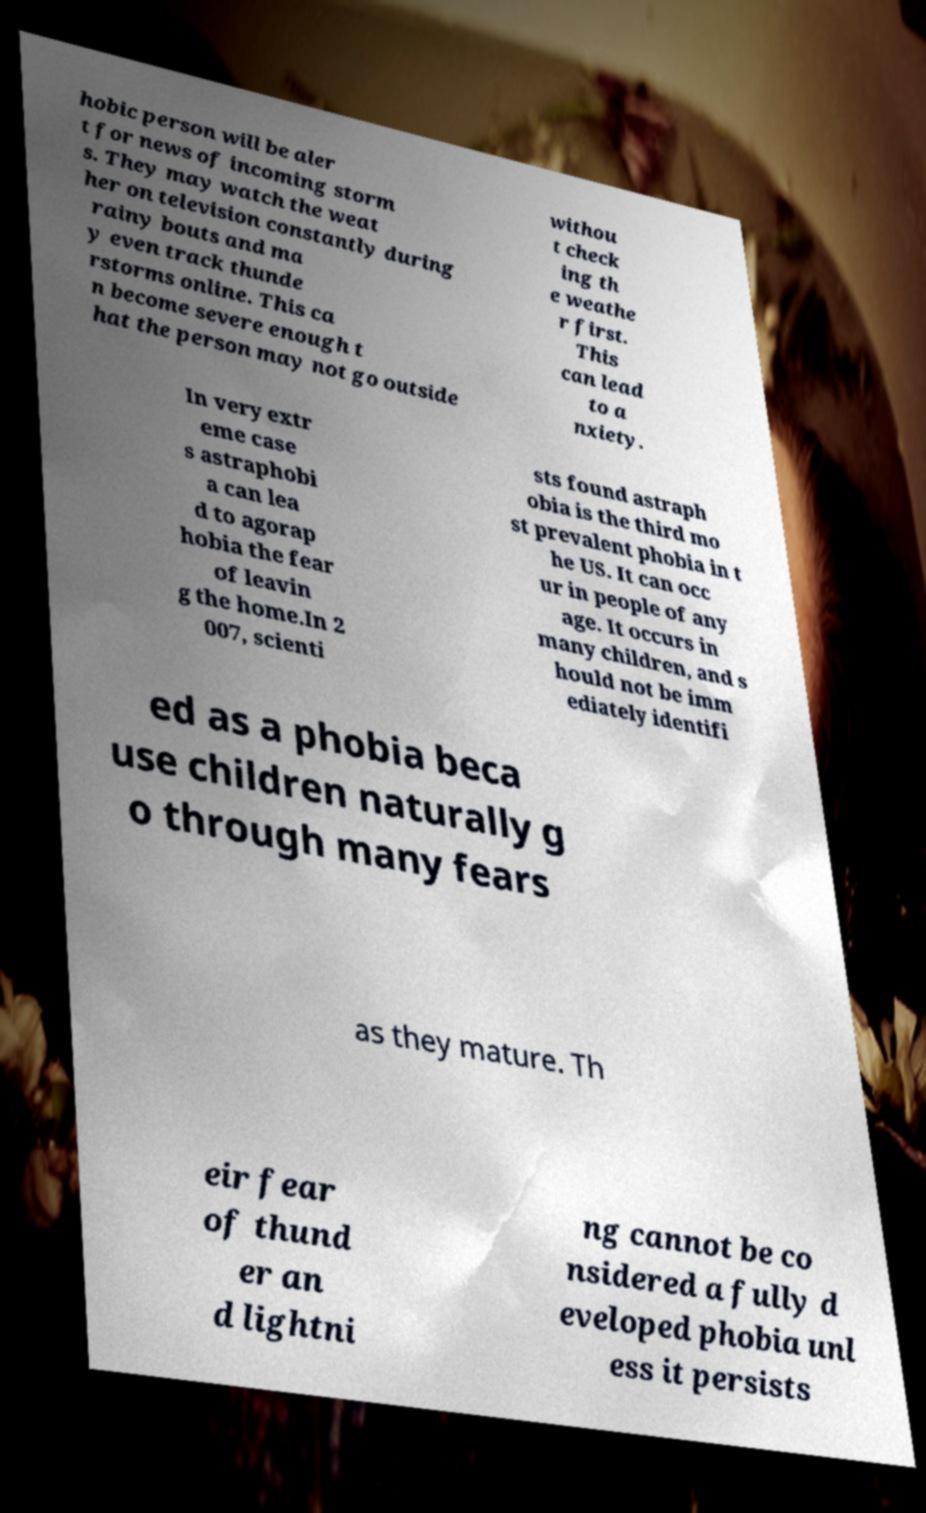Can you read and provide the text displayed in the image?This photo seems to have some interesting text. Can you extract and type it out for me? hobic person will be aler t for news of incoming storm s. They may watch the weat her on television constantly during rainy bouts and ma y even track thunde rstorms online. This ca n become severe enough t hat the person may not go outside withou t check ing th e weathe r first. This can lead to a nxiety. In very extr eme case s astraphobi a can lea d to agorap hobia the fear of leavin g the home.In 2 007, scienti sts found astraph obia is the third mo st prevalent phobia in t he US. It can occ ur in people of any age. It occurs in many children, and s hould not be imm ediately identifi ed as a phobia beca use children naturally g o through many fears as they mature. Th eir fear of thund er an d lightni ng cannot be co nsidered a fully d eveloped phobia unl ess it persists 